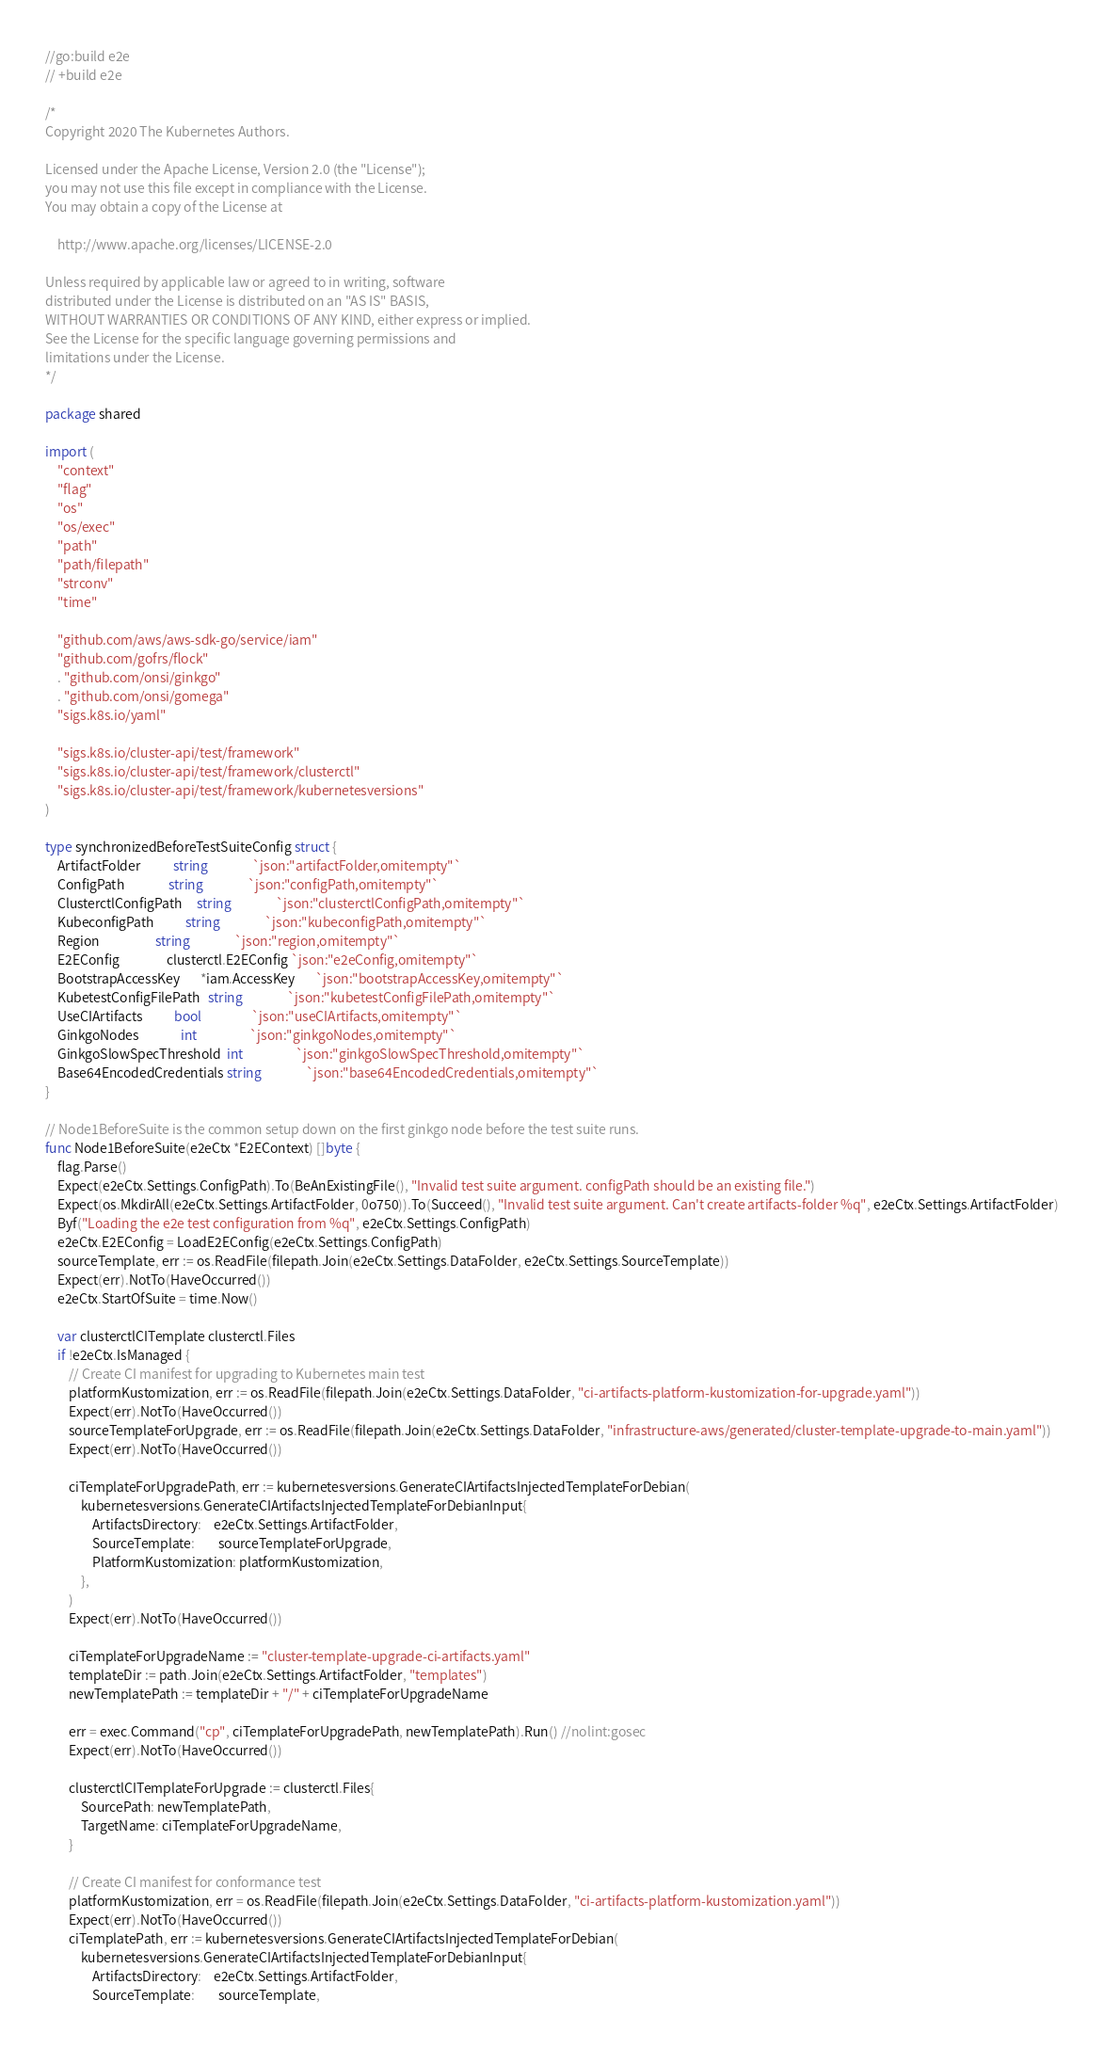<code> <loc_0><loc_0><loc_500><loc_500><_Go_>//go:build e2e
// +build e2e

/*
Copyright 2020 The Kubernetes Authors.

Licensed under the Apache License, Version 2.0 (the "License");
you may not use this file except in compliance with the License.
You may obtain a copy of the License at

    http://www.apache.org/licenses/LICENSE-2.0

Unless required by applicable law or agreed to in writing, software
distributed under the License is distributed on an "AS IS" BASIS,
WITHOUT WARRANTIES OR CONDITIONS OF ANY KIND, either express or implied.
See the License for the specific language governing permissions and
limitations under the License.
*/

package shared

import (
	"context"
	"flag"
	"os"
	"os/exec"
	"path"
	"path/filepath"
	"strconv"
	"time"

	"github.com/aws/aws-sdk-go/service/iam"
	"github.com/gofrs/flock"
	. "github.com/onsi/ginkgo"
	. "github.com/onsi/gomega"
	"sigs.k8s.io/yaml"

	"sigs.k8s.io/cluster-api/test/framework"
	"sigs.k8s.io/cluster-api/test/framework/clusterctl"
	"sigs.k8s.io/cluster-api/test/framework/kubernetesversions"
)

type synchronizedBeforeTestSuiteConfig struct {
	ArtifactFolder           string               `json:"artifactFolder,omitempty"`
	ConfigPath               string               `json:"configPath,omitempty"`
	ClusterctlConfigPath     string               `json:"clusterctlConfigPath,omitempty"`
	KubeconfigPath           string               `json:"kubeconfigPath,omitempty"`
	Region                   string               `json:"region,omitempty"`
	E2EConfig                clusterctl.E2EConfig `json:"e2eConfig,omitempty"`
	BootstrapAccessKey       *iam.AccessKey       `json:"bootstrapAccessKey,omitempty"`
	KubetestConfigFilePath   string               `json:"kubetestConfigFilePath,omitempty"`
	UseCIArtifacts           bool                 `json:"useCIArtifacts,omitempty"`
	GinkgoNodes              int                  `json:"ginkgoNodes,omitempty"`
	GinkgoSlowSpecThreshold  int                  `json:"ginkgoSlowSpecThreshold,omitempty"`
	Base64EncodedCredentials string               `json:"base64EncodedCredentials,omitempty"`
}

// Node1BeforeSuite is the common setup down on the first ginkgo node before the test suite runs.
func Node1BeforeSuite(e2eCtx *E2EContext) []byte {
	flag.Parse()
	Expect(e2eCtx.Settings.ConfigPath).To(BeAnExistingFile(), "Invalid test suite argument. configPath should be an existing file.")
	Expect(os.MkdirAll(e2eCtx.Settings.ArtifactFolder, 0o750)).To(Succeed(), "Invalid test suite argument. Can't create artifacts-folder %q", e2eCtx.Settings.ArtifactFolder)
	Byf("Loading the e2e test configuration from %q", e2eCtx.Settings.ConfigPath)
	e2eCtx.E2EConfig = LoadE2EConfig(e2eCtx.Settings.ConfigPath)
	sourceTemplate, err := os.ReadFile(filepath.Join(e2eCtx.Settings.DataFolder, e2eCtx.Settings.SourceTemplate))
	Expect(err).NotTo(HaveOccurred())
	e2eCtx.StartOfSuite = time.Now()

	var clusterctlCITemplate clusterctl.Files
	if !e2eCtx.IsManaged {
		// Create CI manifest for upgrading to Kubernetes main test
		platformKustomization, err := os.ReadFile(filepath.Join(e2eCtx.Settings.DataFolder, "ci-artifacts-platform-kustomization-for-upgrade.yaml"))
		Expect(err).NotTo(HaveOccurred())
		sourceTemplateForUpgrade, err := os.ReadFile(filepath.Join(e2eCtx.Settings.DataFolder, "infrastructure-aws/generated/cluster-template-upgrade-to-main.yaml"))
		Expect(err).NotTo(HaveOccurred())

		ciTemplateForUpgradePath, err := kubernetesversions.GenerateCIArtifactsInjectedTemplateForDebian(
			kubernetesversions.GenerateCIArtifactsInjectedTemplateForDebianInput{
				ArtifactsDirectory:    e2eCtx.Settings.ArtifactFolder,
				SourceTemplate:        sourceTemplateForUpgrade,
				PlatformKustomization: platformKustomization,
			},
		)
		Expect(err).NotTo(HaveOccurred())

		ciTemplateForUpgradeName := "cluster-template-upgrade-ci-artifacts.yaml"
		templateDir := path.Join(e2eCtx.Settings.ArtifactFolder, "templates")
		newTemplatePath := templateDir + "/" + ciTemplateForUpgradeName

		err = exec.Command("cp", ciTemplateForUpgradePath, newTemplatePath).Run() //nolint:gosec
		Expect(err).NotTo(HaveOccurred())

		clusterctlCITemplateForUpgrade := clusterctl.Files{
			SourcePath: newTemplatePath,
			TargetName: ciTemplateForUpgradeName,
		}

		// Create CI manifest for conformance test
		platformKustomization, err = os.ReadFile(filepath.Join(e2eCtx.Settings.DataFolder, "ci-artifacts-platform-kustomization.yaml"))
		Expect(err).NotTo(HaveOccurred())
		ciTemplatePath, err := kubernetesversions.GenerateCIArtifactsInjectedTemplateForDebian(
			kubernetesversions.GenerateCIArtifactsInjectedTemplateForDebianInput{
				ArtifactsDirectory:    e2eCtx.Settings.ArtifactFolder,
				SourceTemplate:        sourceTemplate,</code> 